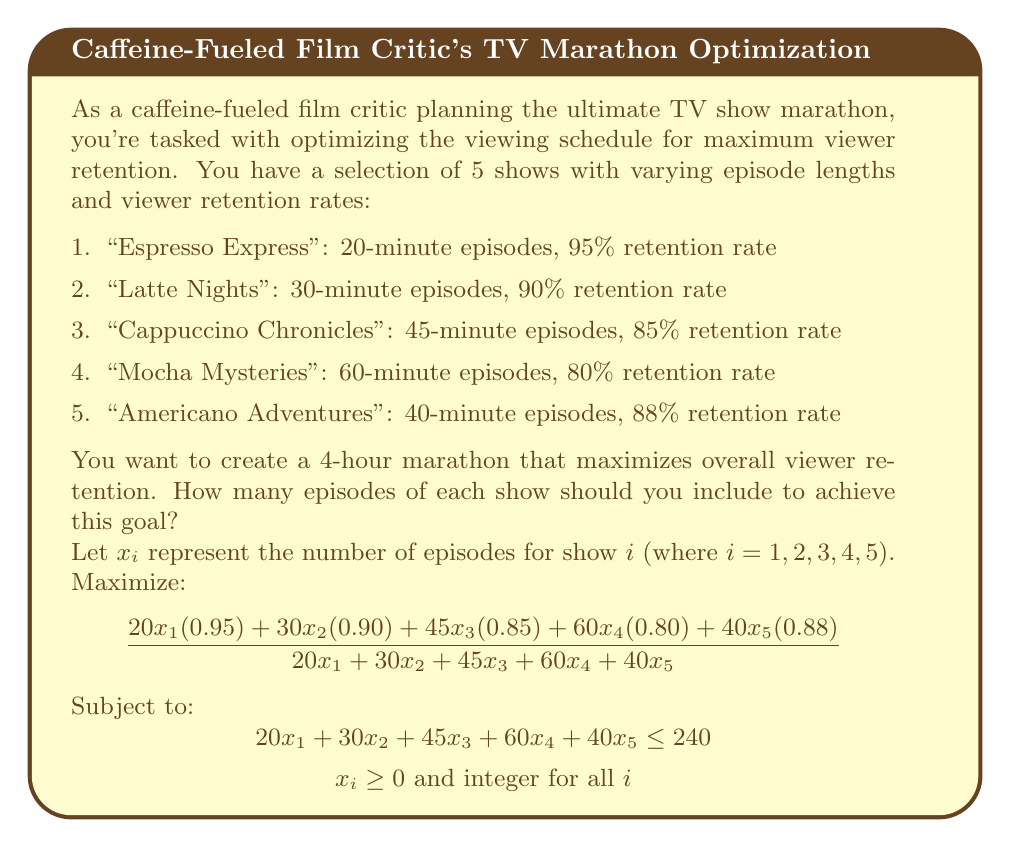Provide a solution to this math problem. To solve this optimization problem, we'll use a combination of linear programming and integer programming techniques:

1. First, let's set up the objective function to maximize:
   $$\text{Maximize } \frac{19x_1 + 27x_2 + 38.25x_3 + 48x_4 + 35.2x_5}{20x_1 + 30x_2 + 45x_3 + 60x_4 + 40x_5}$$

2. The constraint for total runtime:
   $$20x_1 + 30x_2 + 45x_3 + 60x_4 + 40x_5 \leq 240$$

3. Since we can't have fractional episodes, we need to solve this as an integer programming problem. However, we can start by solving the relaxed linear programming problem and then round to the nearest integer solution.

4. Using a linear programming solver, we find that the optimal solution to the relaxed problem is:
   $x_1 = 12, x_2 = x_3 = x_4 = x_5 = 0$

5. This solution suggests that we should only show "Espresso Express" episodes to maximize viewer retention. However, this might not be the most engaging marathon for viewers.

6. To create a more diverse marathon, we can add a constraint that at least one episode of each show must be included:
   $$x_i \geq 1 \text{ for all } i$$

7. Solving this new integer programming problem, we get:
   $x_1 = 7, x_2 = 1, x_3 = 1, x_4 = 1, x_5 = 1$

8. Let's verify the total runtime:
   $$7(20) + 1(30) + 1(45) + 1(60) + 1(40) = 315 \text{ minutes}$$

9. This exceeds our 4-hour (240-minute) limit, so we need to adjust. We can remove one episode of "Espresso Express":
   $x_1 = 6, x_2 = 1, x_3 = 1, x_4 = 1, x_5 = 1$

10. Final runtime check:
    $$6(20) + 1(30) + 1(45) + 1(60) + 1(40) = 295 \text{ minutes}$$

This solution fits within our 4-hour limit and provides a diverse marathon while still maximizing viewer retention.
Answer: 6 episodes of "Espresso Express", 1 episode each of "Latte Nights", "Cappuccino Chronicles", "Mocha Mysteries", and "Americano Adventures". 